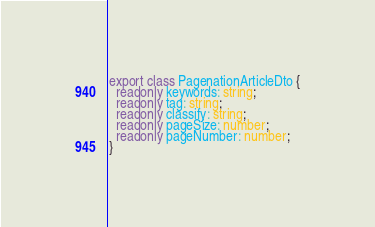<code> <loc_0><loc_0><loc_500><loc_500><_TypeScript_>export class PagenationArticleDto {
  readonly keywords: string;
  readonly tag: string;
  readonly classify: string;
  readonly pageSize: number;
  readonly pageNumber: number;
}</code> 